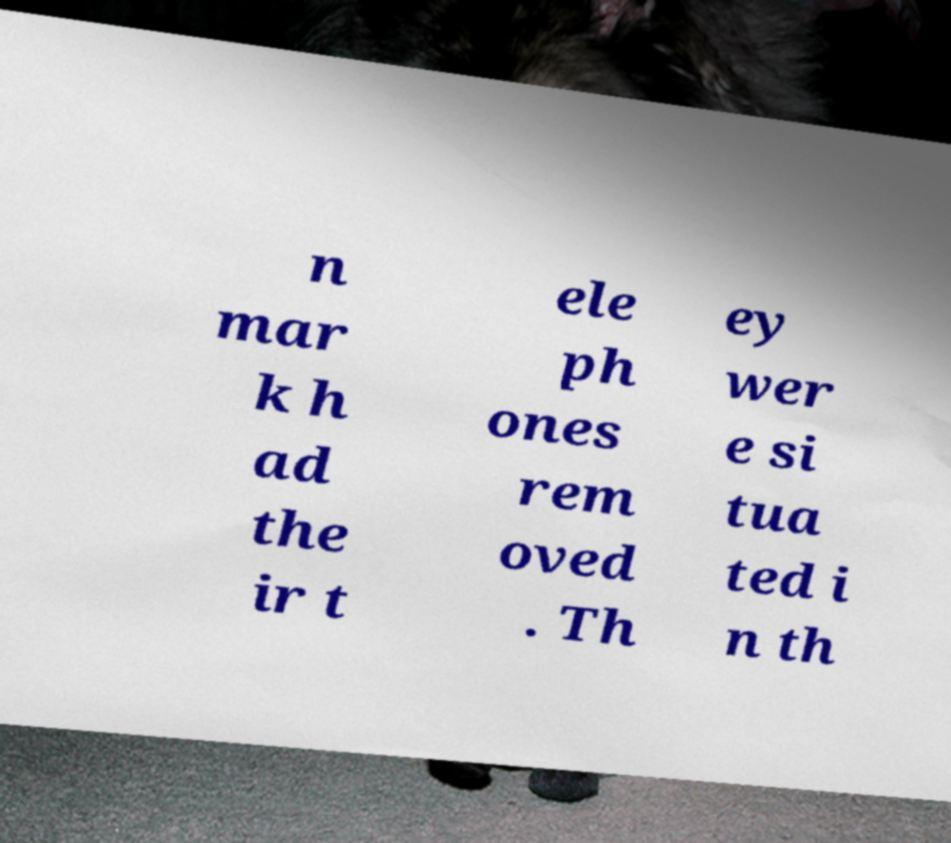I need the written content from this picture converted into text. Can you do that? n mar k h ad the ir t ele ph ones rem oved . Th ey wer e si tua ted i n th 